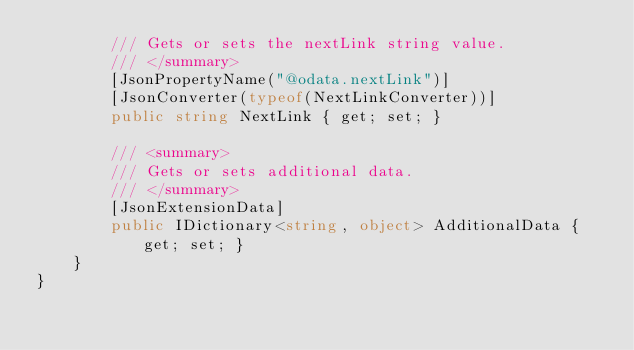Convert code to text. <code><loc_0><loc_0><loc_500><loc_500><_C#_>        /// Gets or sets the nextLink string value.
        /// </summary>
        [JsonPropertyName("@odata.nextLink")]
        [JsonConverter(typeof(NextLinkConverter))]
        public string NextLink { get; set; }

        /// <summary>
        /// Gets or sets additional data.
        /// </summary>
        [JsonExtensionData]
        public IDictionary<string, object> AdditionalData { get; set; }
    }
}
</code> 